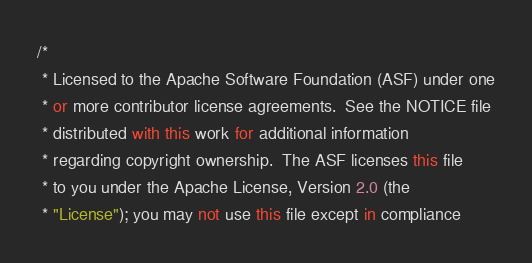<code> <loc_0><loc_0><loc_500><loc_500><_C#_>/*
 * Licensed to the Apache Software Foundation (ASF) under one
 * or more contributor license agreements.  See the NOTICE file
 * distributed with this work for additional information
 * regarding copyright ownership.  The ASF licenses this file
 * to you under the Apache License, Version 2.0 (the
 * "License"); you may not use this file except in compliance</code> 